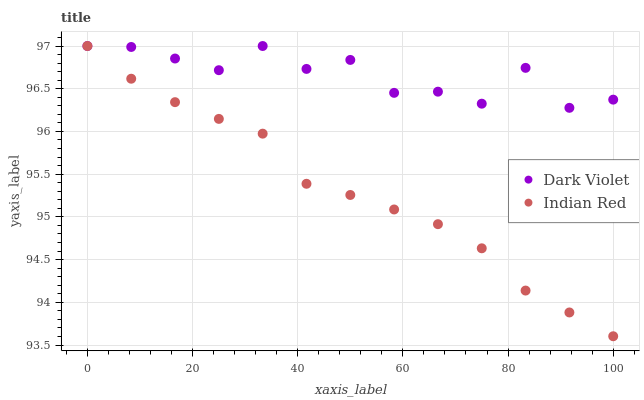Does Indian Red have the minimum area under the curve?
Answer yes or no. Yes. Does Dark Violet have the maximum area under the curve?
Answer yes or no. Yes. Does Dark Violet have the minimum area under the curve?
Answer yes or no. No. Is Indian Red the smoothest?
Answer yes or no. Yes. Is Dark Violet the roughest?
Answer yes or no. Yes. Is Dark Violet the smoothest?
Answer yes or no. No. Does Indian Red have the lowest value?
Answer yes or no. Yes. Does Dark Violet have the lowest value?
Answer yes or no. No. Does Dark Violet have the highest value?
Answer yes or no. Yes. Does Indian Red intersect Dark Violet?
Answer yes or no. Yes. Is Indian Red less than Dark Violet?
Answer yes or no. No. Is Indian Red greater than Dark Violet?
Answer yes or no. No. 